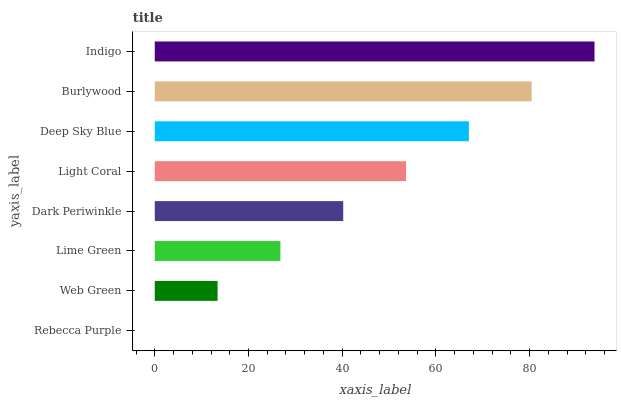Is Rebecca Purple the minimum?
Answer yes or no. Yes. Is Indigo the maximum?
Answer yes or no. Yes. Is Web Green the minimum?
Answer yes or no. No. Is Web Green the maximum?
Answer yes or no. No. Is Web Green greater than Rebecca Purple?
Answer yes or no. Yes. Is Rebecca Purple less than Web Green?
Answer yes or no. Yes. Is Rebecca Purple greater than Web Green?
Answer yes or no. No. Is Web Green less than Rebecca Purple?
Answer yes or no. No. Is Light Coral the high median?
Answer yes or no. Yes. Is Dark Periwinkle the low median?
Answer yes or no. Yes. Is Lime Green the high median?
Answer yes or no. No. Is Lime Green the low median?
Answer yes or no. No. 